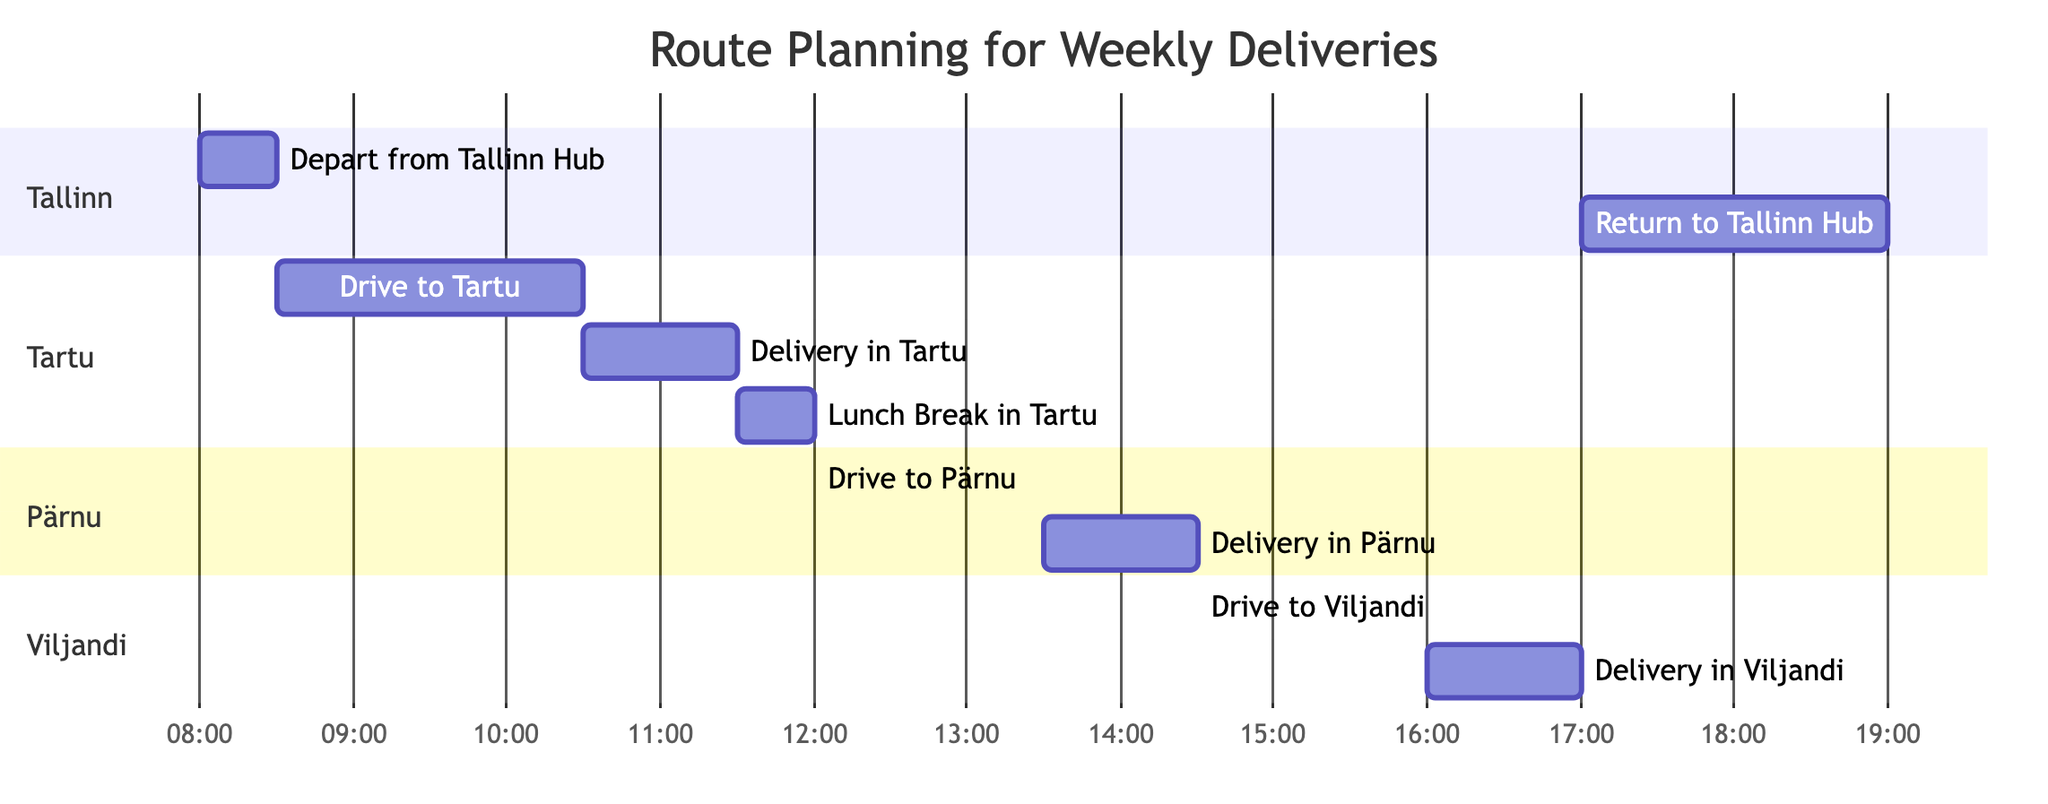What is the duration of the drive to Tartu? In the diagram, the task labeled "Drive to Tartu" shows a duration of "2 hours".
Answer: 2 hours What time does the delivery in Pärnu start? The task labeled "Delivery in Pärnu" starts at "13:30", which is indicated in the Gantt Chart.
Answer: 13:30 How many total tasks are shown in the diagram? To find the total tasks, we can count each individual task listed in the data, which sums up to 9 tasks.
Answer: 9 What is the duration of the lunch break in Tartu? The duration is clearly marked in the Gantt Chart next to "Lunch Break in Tartu", which is "30 minutes".
Answer: 30 minutes Which task immediately follows the delivery in Tartu? The next task after "Delivery in Tartu" is "Lunch Break in Tartu", as it follows directly in the sequence of tasks.
Answer: Lunch Break in Tartu What is the total travel time from Tallinn to Viljandi? We need to add the duration of "Drive to Tartu" (2 hours) and "Drive to Pärnu" (1.5 hours) and "Drive to Viljandi" (1.5 hours), which totals 5 hours.
Answer: 5 hours What time does the truck return to Tallinn Hub? The "Return to Tallinn Hub" task is indicated to end at "19:00", according to the Gantt Chart.
Answer: 19:00 What task occurs after the lunch break in Tartu? The task that happens immediately after "Lunch Break in Tartu" is "Drive to Pärnu", as per the sequence shown in the Gantt Chart.
Answer: Drive to Pärnu What is the duration of the delivery in Viljandi? The task labeled "Delivery in Viljandi" is marked with a duration of "1 hour".
Answer: 1 hour 